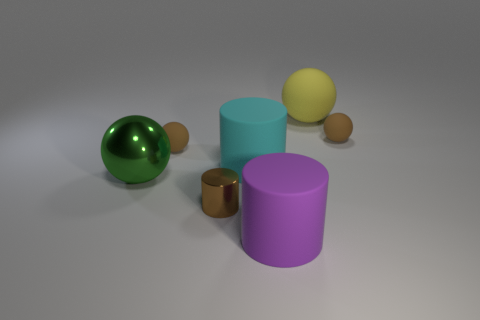Subtract all red blocks. How many brown balls are left? 2 Subtract 1 cylinders. How many cylinders are left? 2 Subtract all big rubber cylinders. How many cylinders are left? 1 Add 2 tiny spheres. How many objects exist? 9 Subtract all yellow spheres. How many spheres are left? 3 Subtract all balls. How many objects are left? 3 Subtract 0 yellow cylinders. How many objects are left? 7 Subtract all cyan balls. Subtract all red blocks. How many balls are left? 4 Subtract all small cylinders. Subtract all metallic objects. How many objects are left? 4 Add 2 metal things. How many metal things are left? 4 